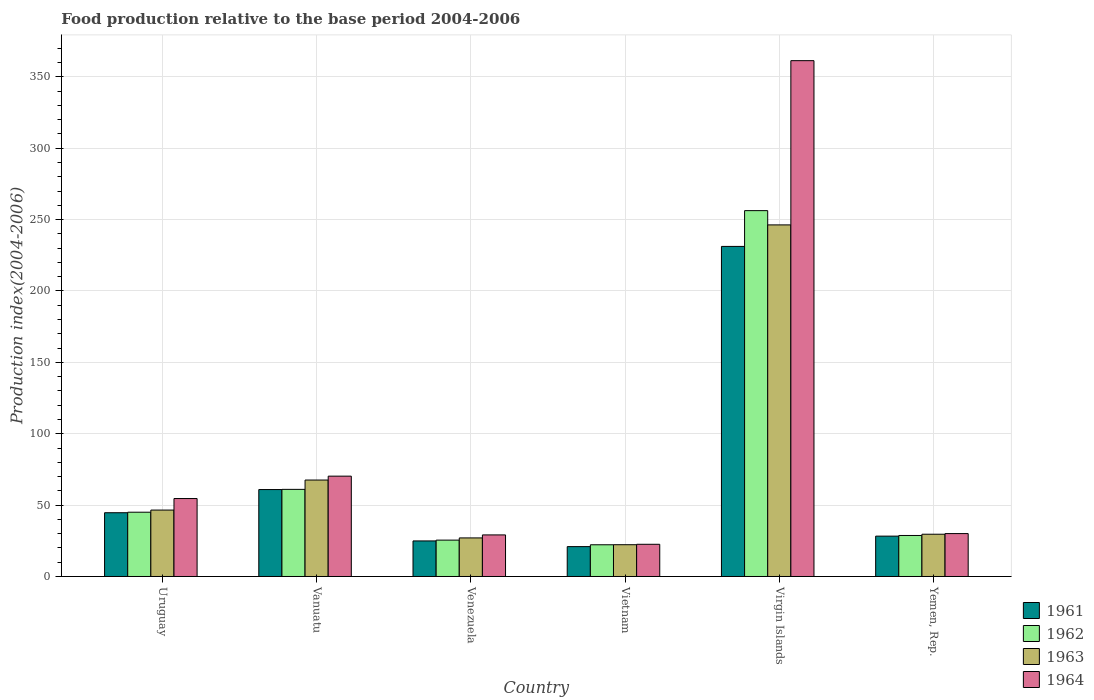How many groups of bars are there?
Provide a short and direct response. 6. Are the number of bars per tick equal to the number of legend labels?
Provide a succinct answer. Yes. Are the number of bars on each tick of the X-axis equal?
Your response must be concise. Yes. How many bars are there on the 5th tick from the right?
Your answer should be very brief. 4. What is the label of the 3rd group of bars from the left?
Your answer should be very brief. Venezuela. What is the food production index in 1961 in Vanuatu?
Your response must be concise. 60.9. Across all countries, what is the maximum food production index in 1961?
Provide a succinct answer. 231.21. Across all countries, what is the minimum food production index in 1964?
Provide a short and direct response. 22.56. In which country was the food production index in 1962 maximum?
Provide a short and direct response. Virgin Islands. In which country was the food production index in 1963 minimum?
Your response must be concise. Vietnam. What is the total food production index in 1964 in the graph?
Offer a terse response. 567.94. What is the difference between the food production index in 1962 in Vanuatu and that in Vietnam?
Your answer should be compact. 38.81. What is the difference between the food production index in 1961 in Vietnam and the food production index in 1962 in Uruguay?
Offer a terse response. -24.1. What is the average food production index in 1962 per country?
Provide a short and direct response. 73.12. What is the difference between the food production index of/in 1961 and food production index of/in 1964 in Virgin Islands?
Your answer should be very brief. -130.11. In how many countries, is the food production index in 1962 greater than 10?
Keep it short and to the point. 6. What is the ratio of the food production index in 1964 in Uruguay to that in Virgin Islands?
Offer a very short reply. 0.15. Is the food production index in 1963 in Venezuela less than that in Virgin Islands?
Provide a short and direct response. Yes. Is the difference between the food production index in 1961 in Venezuela and Virgin Islands greater than the difference between the food production index in 1964 in Venezuela and Virgin Islands?
Provide a succinct answer. Yes. What is the difference between the highest and the second highest food production index in 1964?
Provide a succinct answer. -306.72. What is the difference between the highest and the lowest food production index in 1962?
Your answer should be compact. 234.05. In how many countries, is the food production index in 1964 greater than the average food production index in 1964 taken over all countries?
Offer a very short reply. 1. What does the 2nd bar from the right in Venezuela represents?
Keep it short and to the point. 1963. What is the difference between two consecutive major ticks on the Y-axis?
Offer a very short reply. 50. Does the graph contain grids?
Your answer should be very brief. Yes. What is the title of the graph?
Give a very brief answer. Food production relative to the base period 2004-2006. Does "2011" appear as one of the legend labels in the graph?
Offer a very short reply. No. What is the label or title of the X-axis?
Provide a short and direct response. Country. What is the label or title of the Y-axis?
Offer a terse response. Production index(2004-2006). What is the Production index(2004-2006) of 1961 in Uruguay?
Your answer should be very brief. 44.66. What is the Production index(2004-2006) of 1962 in Uruguay?
Provide a short and direct response. 45.02. What is the Production index(2004-2006) of 1963 in Uruguay?
Keep it short and to the point. 46.52. What is the Production index(2004-2006) in 1964 in Uruguay?
Offer a terse response. 54.6. What is the Production index(2004-2006) of 1961 in Vanuatu?
Provide a short and direct response. 60.9. What is the Production index(2004-2006) of 1962 in Vanuatu?
Give a very brief answer. 61.03. What is the Production index(2004-2006) of 1963 in Vanuatu?
Your answer should be compact. 67.56. What is the Production index(2004-2006) in 1964 in Vanuatu?
Give a very brief answer. 70.29. What is the Production index(2004-2006) in 1961 in Venezuela?
Provide a short and direct response. 24.91. What is the Production index(2004-2006) in 1962 in Venezuela?
Provide a succinct answer. 25.48. What is the Production index(2004-2006) in 1963 in Venezuela?
Keep it short and to the point. 27.02. What is the Production index(2004-2006) of 1964 in Venezuela?
Make the answer very short. 29.12. What is the Production index(2004-2006) in 1961 in Vietnam?
Give a very brief answer. 20.92. What is the Production index(2004-2006) of 1962 in Vietnam?
Make the answer very short. 22.22. What is the Production index(2004-2006) in 1963 in Vietnam?
Make the answer very short. 22.26. What is the Production index(2004-2006) of 1964 in Vietnam?
Keep it short and to the point. 22.56. What is the Production index(2004-2006) in 1961 in Virgin Islands?
Offer a very short reply. 231.21. What is the Production index(2004-2006) in 1962 in Virgin Islands?
Keep it short and to the point. 256.27. What is the Production index(2004-2006) in 1963 in Virgin Islands?
Your answer should be compact. 246.28. What is the Production index(2004-2006) in 1964 in Virgin Islands?
Make the answer very short. 361.32. What is the Production index(2004-2006) in 1961 in Yemen, Rep.?
Provide a short and direct response. 28.27. What is the Production index(2004-2006) in 1962 in Yemen, Rep.?
Keep it short and to the point. 28.73. What is the Production index(2004-2006) of 1963 in Yemen, Rep.?
Keep it short and to the point. 29.6. What is the Production index(2004-2006) in 1964 in Yemen, Rep.?
Provide a short and direct response. 30.05. Across all countries, what is the maximum Production index(2004-2006) in 1961?
Your answer should be very brief. 231.21. Across all countries, what is the maximum Production index(2004-2006) of 1962?
Keep it short and to the point. 256.27. Across all countries, what is the maximum Production index(2004-2006) in 1963?
Give a very brief answer. 246.28. Across all countries, what is the maximum Production index(2004-2006) of 1964?
Offer a terse response. 361.32. Across all countries, what is the minimum Production index(2004-2006) in 1961?
Keep it short and to the point. 20.92. Across all countries, what is the minimum Production index(2004-2006) of 1962?
Keep it short and to the point. 22.22. Across all countries, what is the minimum Production index(2004-2006) of 1963?
Your response must be concise. 22.26. Across all countries, what is the minimum Production index(2004-2006) of 1964?
Your answer should be very brief. 22.56. What is the total Production index(2004-2006) in 1961 in the graph?
Your response must be concise. 410.87. What is the total Production index(2004-2006) of 1962 in the graph?
Your answer should be very brief. 438.75. What is the total Production index(2004-2006) of 1963 in the graph?
Your answer should be very brief. 439.24. What is the total Production index(2004-2006) in 1964 in the graph?
Provide a short and direct response. 567.94. What is the difference between the Production index(2004-2006) of 1961 in Uruguay and that in Vanuatu?
Your response must be concise. -16.24. What is the difference between the Production index(2004-2006) of 1962 in Uruguay and that in Vanuatu?
Provide a short and direct response. -16.01. What is the difference between the Production index(2004-2006) of 1963 in Uruguay and that in Vanuatu?
Your response must be concise. -21.04. What is the difference between the Production index(2004-2006) of 1964 in Uruguay and that in Vanuatu?
Your response must be concise. -15.69. What is the difference between the Production index(2004-2006) of 1961 in Uruguay and that in Venezuela?
Keep it short and to the point. 19.75. What is the difference between the Production index(2004-2006) in 1962 in Uruguay and that in Venezuela?
Offer a very short reply. 19.54. What is the difference between the Production index(2004-2006) in 1963 in Uruguay and that in Venezuela?
Your answer should be very brief. 19.5. What is the difference between the Production index(2004-2006) of 1964 in Uruguay and that in Venezuela?
Your answer should be very brief. 25.48. What is the difference between the Production index(2004-2006) of 1961 in Uruguay and that in Vietnam?
Ensure brevity in your answer.  23.74. What is the difference between the Production index(2004-2006) in 1962 in Uruguay and that in Vietnam?
Offer a very short reply. 22.8. What is the difference between the Production index(2004-2006) of 1963 in Uruguay and that in Vietnam?
Offer a terse response. 24.26. What is the difference between the Production index(2004-2006) in 1964 in Uruguay and that in Vietnam?
Your answer should be compact. 32.04. What is the difference between the Production index(2004-2006) of 1961 in Uruguay and that in Virgin Islands?
Offer a terse response. -186.55. What is the difference between the Production index(2004-2006) of 1962 in Uruguay and that in Virgin Islands?
Your answer should be compact. -211.25. What is the difference between the Production index(2004-2006) in 1963 in Uruguay and that in Virgin Islands?
Your answer should be compact. -199.76. What is the difference between the Production index(2004-2006) of 1964 in Uruguay and that in Virgin Islands?
Your response must be concise. -306.72. What is the difference between the Production index(2004-2006) of 1961 in Uruguay and that in Yemen, Rep.?
Your answer should be compact. 16.39. What is the difference between the Production index(2004-2006) in 1962 in Uruguay and that in Yemen, Rep.?
Offer a terse response. 16.29. What is the difference between the Production index(2004-2006) of 1963 in Uruguay and that in Yemen, Rep.?
Your answer should be very brief. 16.92. What is the difference between the Production index(2004-2006) in 1964 in Uruguay and that in Yemen, Rep.?
Provide a succinct answer. 24.55. What is the difference between the Production index(2004-2006) in 1961 in Vanuatu and that in Venezuela?
Offer a terse response. 35.99. What is the difference between the Production index(2004-2006) in 1962 in Vanuatu and that in Venezuela?
Ensure brevity in your answer.  35.55. What is the difference between the Production index(2004-2006) of 1963 in Vanuatu and that in Venezuela?
Your answer should be very brief. 40.54. What is the difference between the Production index(2004-2006) of 1964 in Vanuatu and that in Venezuela?
Your answer should be compact. 41.17. What is the difference between the Production index(2004-2006) of 1961 in Vanuatu and that in Vietnam?
Ensure brevity in your answer.  39.98. What is the difference between the Production index(2004-2006) in 1962 in Vanuatu and that in Vietnam?
Keep it short and to the point. 38.81. What is the difference between the Production index(2004-2006) in 1963 in Vanuatu and that in Vietnam?
Make the answer very short. 45.3. What is the difference between the Production index(2004-2006) of 1964 in Vanuatu and that in Vietnam?
Your answer should be compact. 47.73. What is the difference between the Production index(2004-2006) in 1961 in Vanuatu and that in Virgin Islands?
Give a very brief answer. -170.31. What is the difference between the Production index(2004-2006) of 1962 in Vanuatu and that in Virgin Islands?
Provide a succinct answer. -195.24. What is the difference between the Production index(2004-2006) in 1963 in Vanuatu and that in Virgin Islands?
Provide a succinct answer. -178.72. What is the difference between the Production index(2004-2006) of 1964 in Vanuatu and that in Virgin Islands?
Provide a succinct answer. -291.03. What is the difference between the Production index(2004-2006) of 1961 in Vanuatu and that in Yemen, Rep.?
Keep it short and to the point. 32.63. What is the difference between the Production index(2004-2006) in 1962 in Vanuatu and that in Yemen, Rep.?
Offer a very short reply. 32.3. What is the difference between the Production index(2004-2006) in 1963 in Vanuatu and that in Yemen, Rep.?
Give a very brief answer. 37.96. What is the difference between the Production index(2004-2006) in 1964 in Vanuatu and that in Yemen, Rep.?
Your answer should be compact. 40.24. What is the difference between the Production index(2004-2006) of 1961 in Venezuela and that in Vietnam?
Your response must be concise. 3.99. What is the difference between the Production index(2004-2006) of 1962 in Venezuela and that in Vietnam?
Offer a terse response. 3.26. What is the difference between the Production index(2004-2006) of 1963 in Venezuela and that in Vietnam?
Give a very brief answer. 4.76. What is the difference between the Production index(2004-2006) in 1964 in Venezuela and that in Vietnam?
Ensure brevity in your answer.  6.56. What is the difference between the Production index(2004-2006) in 1961 in Venezuela and that in Virgin Islands?
Give a very brief answer. -206.3. What is the difference between the Production index(2004-2006) of 1962 in Venezuela and that in Virgin Islands?
Your response must be concise. -230.79. What is the difference between the Production index(2004-2006) in 1963 in Venezuela and that in Virgin Islands?
Your response must be concise. -219.26. What is the difference between the Production index(2004-2006) in 1964 in Venezuela and that in Virgin Islands?
Your response must be concise. -332.2. What is the difference between the Production index(2004-2006) in 1961 in Venezuela and that in Yemen, Rep.?
Your response must be concise. -3.36. What is the difference between the Production index(2004-2006) in 1962 in Venezuela and that in Yemen, Rep.?
Keep it short and to the point. -3.25. What is the difference between the Production index(2004-2006) of 1963 in Venezuela and that in Yemen, Rep.?
Your answer should be very brief. -2.58. What is the difference between the Production index(2004-2006) in 1964 in Venezuela and that in Yemen, Rep.?
Your answer should be compact. -0.93. What is the difference between the Production index(2004-2006) in 1961 in Vietnam and that in Virgin Islands?
Provide a short and direct response. -210.29. What is the difference between the Production index(2004-2006) in 1962 in Vietnam and that in Virgin Islands?
Ensure brevity in your answer.  -234.05. What is the difference between the Production index(2004-2006) of 1963 in Vietnam and that in Virgin Islands?
Your response must be concise. -224.02. What is the difference between the Production index(2004-2006) of 1964 in Vietnam and that in Virgin Islands?
Offer a very short reply. -338.76. What is the difference between the Production index(2004-2006) in 1961 in Vietnam and that in Yemen, Rep.?
Give a very brief answer. -7.35. What is the difference between the Production index(2004-2006) of 1962 in Vietnam and that in Yemen, Rep.?
Your answer should be compact. -6.51. What is the difference between the Production index(2004-2006) in 1963 in Vietnam and that in Yemen, Rep.?
Provide a succinct answer. -7.34. What is the difference between the Production index(2004-2006) in 1964 in Vietnam and that in Yemen, Rep.?
Provide a succinct answer. -7.49. What is the difference between the Production index(2004-2006) of 1961 in Virgin Islands and that in Yemen, Rep.?
Provide a short and direct response. 202.94. What is the difference between the Production index(2004-2006) of 1962 in Virgin Islands and that in Yemen, Rep.?
Make the answer very short. 227.54. What is the difference between the Production index(2004-2006) of 1963 in Virgin Islands and that in Yemen, Rep.?
Your answer should be very brief. 216.68. What is the difference between the Production index(2004-2006) of 1964 in Virgin Islands and that in Yemen, Rep.?
Provide a succinct answer. 331.27. What is the difference between the Production index(2004-2006) of 1961 in Uruguay and the Production index(2004-2006) of 1962 in Vanuatu?
Provide a succinct answer. -16.37. What is the difference between the Production index(2004-2006) of 1961 in Uruguay and the Production index(2004-2006) of 1963 in Vanuatu?
Provide a short and direct response. -22.9. What is the difference between the Production index(2004-2006) of 1961 in Uruguay and the Production index(2004-2006) of 1964 in Vanuatu?
Keep it short and to the point. -25.63. What is the difference between the Production index(2004-2006) in 1962 in Uruguay and the Production index(2004-2006) in 1963 in Vanuatu?
Make the answer very short. -22.54. What is the difference between the Production index(2004-2006) of 1962 in Uruguay and the Production index(2004-2006) of 1964 in Vanuatu?
Your answer should be compact. -25.27. What is the difference between the Production index(2004-2006) in 1963 in Uruguay and the Production index(2004-2006) in 1964 in Vanuatu?
Ensure brevity in your answer.  -23.77. What is the difference between the Production index(2004-2006) in 1961 in Uruguay and the Production index(2004-2006) in 1962 in Venezuela?
Your answer should be very brief. 19.18. What is the difference between the Production index(2004-2006) of 1961 in Uruguay and the Production index(2004-2006) of 1963 in Venezuela?
Keep it short and to the point. 17.64. What is the difference between the Production index(2004-2006) of 1961 in Uruguay and the Production index(2004-2006) of 1964 in Venezuela?
Make the answer very short. 15.54. What is the difference between the Production index(2004-2006) in 1962 in Uruguay and the Production index(2004-2006) in 1964 in Venezuela?
Give a very brief answer. 15.9. What is the difference between the Production index(2004-2006) in 1961 in Uruguay and the Production index(2004-2006) in 1962 in Vietnam?
Provide a succinct answer. 22.44. What is the difference between the Production index(2004-2006) in 1961 in Uruguay and the Production index(2004-2006) in 1963 in Vietnam?
Your answer should be compact. 22.4. What is the difference between the Production index(2004-2006) of 1961 in Uruguay and the Production index(2004-2006) of 1964 in Vietnam?
Offer a very short reply. 22.1. What is the difference between the Production index(2004-2006) of 1962 in Uruguay and the Production index(2004-2006) of 1963 in Vietnam?
Offer a very short reply. 22.76. What is the difference between the Production index(2004-2006) of 1962 in Uruguay and the Production index(2004-2006) of 1964 in Vietnam?
Your response must be concise. 22.46. What is the difference between the Production index(2004-2006) in 1963 in Uruguay and the Production index(2004-2006) in 1964 in Vietnam?
Keep it short and to the point. 23.96. What is the difference between the Production index(2004-2006) in 1961 in Uruguay and the Production index(2004-2006) in 1962 in Virgin Islands?
Provide a succinct answer. -211.61. What is the difference between the Production index(2004-2006) in 1961 in Uruguay and the Production index(2004-2006) in 1963 in Virgin Islands?
Ensure brevity in your answer.  -201.62. What is the difference between the Production index(2004-2006) of 1961 in Uruguay and the Production index(2004-2006) of 1964 in Virgin Islands?
Make the answer very short. -316.66. What is the difference between the Production index(2004-2006) of 1962 in Uruguay and the Production index(2004-2006) of 1963 in Virgin Islands?
Offer a terse response. -201.26. What is the difference between the Production index(2004-2006) in 1962 in Uruguay and the Production index(2004-2006) in 1964 in Virgin Islands?
Make the answer very short. -316.3. What is the difference between the Production index(2004-2006) in 1963 in Uruguay and the Production index(2004-2006) in 1964 in Virgin Islands?
Offer a very short reply. -314.8. What is the difference between the Production index(2004-2006) of 1961 in Uruguay and the Production index(2004-2006) of 1962 in Yemen, Rep.?
Your answer should be compact. 15.93. What is the difference between the Production index(2004-2006) of 1961 in Uruguay and the Production index(2004-2006) of 1963 in Yemen, Rep.?
Your answer should be compact. 15.06. What is the difference between the Production index(2004-2006) in 1961 in Uruguay and the Production index(2004-2006) in 1964 in Yemen, Rep.?
Keep it short and to the point. 14.61. What is the difference between the Production index(2004-2006) in 1962 in Uruguay and the Production index(2004-2006) in 1963 in Yemen, Rep.?
Make the answer very short. 15.42. What is the difference between the Production index(2004-2006) of 1962 in Uruguay and the Production index(2004-2006) of 1964 in Yemen, Rep.?
Give a very brief answer. 14.97. What is the difference between the Production index(2004-2006) of 1963 in Uruguay and the Production index(2004-2006) of 1964 in Yemen, Rep.?
Offer a very short reply. 16.47. What is the difference between the Production index(2004-2006) in 1961 in Vanuatu and the Production index(2004-2006) in 1962 in Venezuela?
Your answer should be compact. 35.42. What is the difference between the Production index(2004-2006) of 1961 in Vanuatu and the Production index(2004-2006) of 1963 in Venezuela?
Make the answer very short. 33.88. What is the difference between the Production index(2004-2006) in 1961 in Vanuatu and the Production index(2004-2006) in 1964 in Venezuela?
Make the answer very short. 31.78. What is the difference between the Production index(2004-2006) of 1962 in Vanuatu and the Production index(2004-2006) of 1963 in Venezuela?
Provide a short and direct response. 34.01. What is the difference between the Production index(2004-2006) of 1962 in Vanuatu and the Production index(2004-2006) of 1964 in Venezuela?
Keep it short and to the point. 31.91. What is the difference between the Production index(2004-2006) in 1963 in Vanuatu and the Production index(2004-2006) in 1964 in Venezuela?
Offer a terse response. 38.44. What is the difference between the Production index(2004-2006) of 1961 in Vanuatu and the Production index(2004-2006) of 1962 in Vietnam?
Your response must be concise. 38.68. What is the difference between the Production index(2004-2006) of 1961 in Vanuatu and the Production index(2004-2006) of 1963 in Vietnam?
Offer a terse response. 38.64. What is the difference between the Production index(2004-2006) in 1961 in Vanuatu and the Production index(2004-2006) in 1964 in Vietnam?
Ensure brevity in your answer.  38.34. What is the difference between the Production index(2004-2006) in 1962 in Vanuatu and the Production index(2004-2006) in 1963 in Vietnam?
Ensure brevity in your answer.  38.77. What is the difference between the Production index(2004-2006) in 1962 in Vanuatu and the Production index(2004-2006) in 1964 in Vietnam?
Your response must be concise. 38.47. What is the difference between the Production index(2004-2006) in 1961 in Vanuatu and the Production index(2004-2006) in 1962 in Virgin Islands?
Give a very brief answer. -195.37. What is the difference between the Production index(2004-2006) of 1961 in Vanuatu and the Production index(2004-2006) of 1963 in Virgin Islands?
Ensure brevity in your answer.  -185.38. What is the difference between the Production index(2004-2006) in 1961 in Vanuatu and the Production index(2004-2006) in 1964 in Virgin Islands?
Ensure brevity in your answer.  -300.42. What is the difference between the Production index(2004-2006) in 1962 in Vanuatu and the Production index(2004-2006) in 1963 in Virgin Islands?
Ensure brevity in your answer.  -185.25. What is the difference between the Production index(2004-2006) in 1962 in Vanuatu and the Production index(2004-2006) in 1964 in Virgin Islands?
Provide a succinct answer. -300.29. What is the difference between the Production index(2004-2006) in 1963 in Vanuatu and the Production index(2004-2006) in 1964 in Virgin Islands?
Your response must be concise. -293.76. What is the difference between the Production index(2004-2006) of 1961 in Vanuatu and the Production index(2004-2006) of 1962 in Yemen, Rep.?
Your answer should be very brief. 32.17. What is the difference between the Production index(2004-2006) in 1961 in Vanuatu and the Production index(2004-2006) in 1963 in Yemen, Rep.?
Provide a succinct answer. 31.3. What is the difference between the Production index(2004-2006) in 1961 in Vanuatu and the Production index(2004-2006) in 1964 in Yemen, Rep.?
Offer a terse response. 30.85. What is the difference between the Production index(2004-2006) of 1962 in Vanuatu and the Production index(2004-2006) of 1963 in Yemen, Rep.?
Your answer should be very brief. 31.43. What is the difference between the Production index(2004-2006) of 1962 in Vanuatu and the Production index(2004-2006) of 1964 in Yemen, Rep.?
Your answer should be very brief. 30.98. What is the difference between the Production index(2004-2006) of 1963 in Vanuatu and the Production index(2004-2006) of 1964 in Yemen, Rep.?
Provide a succinct answer. 37.51. What is the difference between the Production index(2004-2006) in 1961 in Venezuela and the Production index(2004-2006) in 1962 in Vietnam?
Keep it short and to the point. 2.69. What is the difference between the Production index(2004-2006) in 1961 in Venezuela and the Production index(2004-2006) in 1963 in Vietnam?
Your answer should be compact. 2.65. What is the difference between the Production index(2004-2006) of 1961 in Venezuela and the Production index(2004-2006) of 1964 in Vietnam?
Your answer should be very brief. 2.35. What is the difference between the Production index(2004-2006) of 1962 in Venezuela and the Production index(2004-2006) of 1963 in Vietnam?
Your answer should be very brief. 3.22. What is the difference between the Production index(2004-2006) in 1962 in Venezuela and the Production index(2004-2006) in 1964 in Vietnam?
Offer a very short reply. 2.92. What is the difference between the Production index(2004-2006) in 1963 in Venezuela and the Production index(2004-2006) in 1964 in Vietnam?
Your answer should be very brief. 4.46. What is the difference between the Production index(2004-2006) of 1961 in Venezuela and the Production index(2004-2006) of 1962 in Virgin Islands?
Make the answer very short. -231.36. What is the difference between the Production index(2004-2006) of 1961 in Venezuela and the Production index(2004-2006) of 1963 in Virgin Islands?
Your answer should be very brief. -221.37. What is the difference between the Production index(2004-2006) in 1961 in Venezuela and the Production index(2004-2006) in 1964 in Virgin Islands?
Provide a short and direct response. -336.41. What is the difference between the Production index(2004-2006) of 1962 in Venezuela and the Production index(2004-2006) of 1963 in Virgin Islands?
Keep it short and to the point. -220.8. What is the difference between the Production index(2004-2006) of 1962 in Venezuela and the Production index(2004-2006) of 1964 in Virgin Islands?
Provide a short and direct response. -335.84. What is the difference between the Production index(2004-2006) in 1963 in Venezuela and the Production index(2004-2006) in 1964 in Virgin Islands?
Provide a short and direct response. -334.3. What is the difference between the Production index(2004-2006) of 1961 in Venezuela and the Production index(2004-2006) of 1962 in Yemen, Rep.?
Provide a short and direct response. -3.82. What is the difference between the Production index(2004-2006) of 1961 in Venezuela and the Production index(2004-2006) of 1963 in Yemen, Rep.?
Your response must be concise. -4.69. What is the difference between the Production index(2004-2006) of 1961 in Venezuela and the Production index(2004-2006) of 1964 in Yemen, Rep.?
Offer a very short reply. -5.14. What is the difference between the Production index(2004-2006) of 1962 in Venezuela and the Production index(2004-2006) of 1963 in Yemen, Rep.?
Your answer should be compact. -4.12. What is the difference between the Production index(2004-2006) of 1962 in Venezuela and the Production index(2004-2006) of 1964 in Yemen, Rep.?
Provide a succinct answer. -4.57. What is the difference between the Production index(2004-2006) in 1963 in Venezuela and the Production index(2004-2006) in 1964 in Yemen, Rep.?
Provide a short and direct response. -3.03. What is the difference between the Production index(2004-2006) of 1961 in Vietnam and the Production index(2004-2006) of 1962 in Virgin Islands?
Offer a terse response. -235.35. What is the difference between the Production index(2004-2006) of 1961 in Vietnam and the Production index(2004-2006) of 1963 in Virgin Islands?
Offer a very short reply. -225.36. What is the difference between the Production index(2004-2006) of 1961 in Vietnam and the Production index(2004-2006) of 1964 in Virgin Islands?
Your response must be concise. -340.4. What is the difference between the Production index(2004-2006) in 1962 in Vietnam and the Production index(2004-2006) in 1963 in Virgin Islands?
Your response must be concise. -224.06. What is the difference between the Production index(2004-2006) in 1962 in Vietnam and the Production index(2004-2006) in 1964 in Virgin Islands?
Ensure brevity in your answer.  -339.1. What is the difference between the Production index(2004-2006) in 1963 in Vietnam and the Production index(2004-2006) in 1964 in Virgin Islands?
Offer a very short reply. -339.06. What is the difference between the Production index(2004-2006) of 1961 in Vietnam and the Production index(2004-2006) of 1962 in Yemen, Rep.?
Provide a short and direct response. -7.81. What is the difference between the Production index(2004-2006) of 1961 in Vietnam and the Production index(2004-2006) of 1963 in Yemen, Rep.?
Make the answer very short. -8.68. What is the difference between the Production index(2004-2006) in 1961 in Vietnam and the Production index(2004-2006) in 1964 in Yemen, Rep.?
Keep it short and to the point. -9.13. What is the difference between the Production index(2004-2006) in 1962 in Vietnam and the Production index(2004-2006) in 1963 in Yemen, Rep.?
Your answer should be compact. -7.38. What is the difference between the Production index(2004-2006) in 1962 in Vietnam and the Production index(2004-2006) in 1964 in Yemen, Rep.?
Your answer should be compact. -7.83. What is the difference between the Production index(2004-2006) in 1963 in Vietnam and the Production index(2004-2006) in 1964 in Yemen, Rep.?
Provide a short and direct response. -7.79. What is the difference between the Production index(2004-2006) of 1961 in Virgin Islands and the Production index(2004-2006) of 1962 in Yemen, Rep.?
Your response must be concise. 202.48. What is the difference between the Production index(2004-2006) of 1961 in Virgin Islands and the Production index(2004-2006) of 1963 in Yemen, Rep.?
Offer a very short reply. 201.61. What is the difference between the Production index(2004-2006) in 1961 in Virgin Islands and the Production index(2004-2006) in 1964 in Yemen, Rep.?
Give a very brief answer. 201.16. What is the difference between the Production index(2004-2006) in 1962 in Virgin Islands and the Production index(2004-2006) in 1963 in Yemen, Rep.?
Provide a succinct answer. 226.67. What is the difference between the Production index(2004-2006) of 1962 in Virgin Islands and the Production index(2004-2006) of 1964 in Yemen, Rep.?
Ensure brevity in your answer.  226.22. What is the difference between the Production index(2004-2006) of 1963 in Virgin Islands and the Production index(2004-2006) of 1964 in Yemen, Rep.?
Give a very brief answer. 216.23. What is the average Production index(2004-2006) of 1961 per country?
Offer a very short reply. 68.48. What is the average Production index(2004-2006) in 1962 per country?
Make the answer very short. 73.12. What is the average Production index(2004-2006) in 1963 per country?
Provide a succinct answer. 73.21. What is the average Production index(2004-2006) in 1964 per country?
Your answer should be compact. 94.66. What is the difference between the Production index(2004-2006) in 1961 and Production index(2004-2006) in 1962 in Uruguay?
Ensure brevity in your answer.  -0.36. What is the difference between the Production index(2004-2006) of 1961 and Production index(2004-2006) of 1963 in Uruguay?
Ensure brevity in your answer.  -1.86. What is the difference between the Production index(2004-2006) of 1961 and Production index(2004-2006) of 1964 in Uruguay?
Offer a very short reply. -9.94. What is the difference between the Production index(2004-2006) of 1962 and Production index(2004-2006) of 1964 in Uruguay?
Ensure brevity in your answer.  -9.58. What is the difference between the Production index(2004-2006) of 1963 and Production index(2004-2006) of 1964 in Uruguay?
Provide a succinct answer. -8.08. What is the difference between the Production index(2004-2006) of 1961 and Production index(2004-2006) of 1962 in Vanuatu?
Offer a terse response. -0.13. What is the difference between the Production index(2004-2006) of 1961 and Production index(2004-2006) of 1963 in Vanuatu?
Keep it short and to the point. -6.66. What is the difference between the Production index(2004-2006) of 1961 and Production index(2004-2006) of 1964 in Vanuatu?
Keep it short and to the point. -9.39. What is the difference between the Production index(2004-2006) of 1962 and Production index(2004-2006) of 1963 in Vanuatu?
Give a very brief answer. -6.53. What is the difference between the Production index(2004-2006) of 1962 and Production index(2004-2006) of 1964 in Vanuatu?
Ensure brevity in your answer.  -9.26. What is the difference between the Production index(2004-2006) in 1963 and Production index(2004-2006) in 1964 in Vanuatu?
Provide a short and direct response. -2.73. What is the difference between the Production index(2004-2006) of 1961 and Production index(2004-2006) of 1962 in Venezuela?
Offer a very short reply. -0.57. What is the difference between the Production index(2004-2006) of 1961 and Production index(2004-2006) of 1963 in Venezuela?
Provide a succinct answer. -2.11. What is the difference between the Production index(2004-2006) of 1961 and Production index(2004-2006) of 1964 in Venezuela?
Offer a terse response. -4.21. What is the difference between the Production index(2004-2006) in 1962 and Production index(2004-2006) in 1963 in Venezuela?
Make the answer very short. -1.54. What is the difference between the Production index(2004-2006) of 1962 and Production index(2004-2006) of 1964 in Venezuela?
Provide a succinct answer. -3.64. What is the difference between the Production index(2004-2006) in 1961 and Production index(2004-2006) in 1963 in Vietnam?
Offer a terse response. -1.34. What is the difference between the Production index(2004-2006) of 1961 and Production index(2004-2006) of 1964 in Vietnam?
Your answer should be compact. -1.64. What is the difference between the Production index(2004-2006) in 1962 and Production index(2004-2006) in 1963 in Vietnam?
Keep it short and to the point. -0.04. What is the difference between the Production index(2004-2006) in 1962 and Production index(2004-2006) in 1964 in Vietnam?
Offer a terse response. -0.34. What is the difference between the Production index(2004-2006) of 1961 and Production index(2004-2006) of 1962 in Virgin Islands?
Give a very brief answer. -25.06. What is the difference between the Production index(2004-2006) of 1961 and Production index(2004-2006) of 1963 in Virgin Islands?
Provide a succinct answer. -15.07. What is the difference between the Production index(2004-2006) in 1961 and Production index(2004-2006) in 1964 in Virgin Islands?
Provide a succinct answer. -130.11. What is the difference between the Production index(2004-2006) in 1962 and Production index(2004-2006) in 1963 in Virgin Islands?
Offer a very short reply. 9.99. What is the difference between the Production index(2004-2006) in 1962 and Production index(2004-2006) in 1964 in Virgin Islands?
Your response must be concise. -105.05. What is the difference between the Production index(2004-2006) in 1963 and Production index(2004-2006) in 1964 in Virgin Islands?
Provide a short and direct response. -115.04. What is the difference between the Production index(2004-2006) of 1961 and Production index(2004-2006) of 1962 in Yemen, Rep.?
Keep it short and to the point. -0.46. What is the difference between the Production index(2004-2006) of 1961 and Production index(2004-2006) of 1963 in Yemen, Rep.?
Offer a very short reply. -1.33. What is the difference between the Production index(2004-2006) in 1961 and Production index(2004-2006) in 1964 in Yemen, Rep.?
Offer a terse response. -1.78. What is the difference between the Production index(2004-2006) of 1962 and Production index(2004-2006) of 1963 in Yemen, Rep.?
Offer a terse response. -0.87. What is the difference between the Production index(2004-2006) in 1962 and Production index(2004-2006) in 1964 in Yemen, Rep.?
Offer a very short reply. -1.32. What is the difference between the Production index(2004-2006) in 1963 and Production index(2004-2006) in 1964 in Yemen, Rep.?
Ensure brevity in your answer.  -0.45. What is the ratio of the Production index(2004-2006) in 1961 in Uruguay to that in Vanuatu?
Keep it short and to the point. 0.73. What is the ratio of the Production index(2004-2006) of 1962 in Uruguay to that in Vanuatu?
Offer a very short reply. 0.74. What is the ratio of the Production index(2004-2006) of 1963 in Uruguay to that in Vanuatu?
Provide a succinct answer. 0.69. What is the ratio of the Production index(2004-2006) of 1964 in Uruguay to that in Vanuatu?
Keep it short and to the point. 0.78. What is the ratio of the Production index(2004-2006) of 1961 in Uruguay to that in Venezuela?
Ensure brevity in your answer.  1.79. What is the ratio of the Production index(2004-2006) in 1962 in Uruguay to that in Venezuela?
Your answer should be compact. 1.77. What is the ratio of the Production index(2004-2006) in 1963 in Uruguay to that in Venezuela?
Make the answer very short. 1.72. What is the ratio of the Production index(2004-2006) of 1964 in Uruguay to that in Venezuela?
Keep it short and to the point. 1.88. What is the ratio of the Production index(2004-2006) in 1961 in Uruguay to that in Vietnam?
Give a very brief answer. 2.13. What is the ratio of the Production index(2004-2006) of 1962 in Uruguay to that in Vietnam?
Give a very brief answer. 2.03. What is the ratio of the Production index(2004-2006) in 1963 in Uruguay to that in Vietnam?
Provide a succinct answer. 2.09. What is the ratio of the Production index(2004-2006) of 1964 in Uruguay to that in Vietnam?
Your answer should be very brief. 2.42. What is the ratio of the Production index(2004-2006) of 1961 in Uruguay to that in Virgin Islands?
Keep it short and to the point. 0.19. What is the ratio of the Production index(2004-2006) of 1962 in Uruguay to that in Virgin Islands?
Your answer should be very brief. 0.18. What is the ratio of the Production index(2004-2006) of 1963 in Uruguay to that in Virgin Islands?
Make the answer very short. 0.19. What is the ratio of the Production index(2004-2006) of 1964 in Uruguay to that in Virgin Islands?
Make the answer very short. 0.15. What is the ratio of the Production index(2004-2006) of 1961 in Uruguay to that in Yemen, Rep.?
Provide a succinct answer. 1.58. What is the ratio of the Production index(2004-2006) of 1962 in Uruguay to that in Yemen, Rep.?
Ensure brevity in your answer.  1.57. What is the ratio of the Production index(2004-2006) in 1963 in Uruguay to that in Yemen, Rep.?
Offer a very short reply. 1.57. What is the ratio of the Production index(2004-2006) in 1964 in Uruguay to that in Yemen, Rep.?
Offer a very short reply. 1.82. What is the ratio of the Production index(2004-2006) of 1961 in Vanuatu to that in Venezuela?
Provide a succinct answer. 2.44. What is the ratio of the Production index(2004-2006) of 1962 in Vanuatu to that in Venezuela?
Your answer should be compact. 2.4. What is the ratio of the Production index(2004-2006) of 1963 in Vanuatu to that in Venezuela?
Ensure brevity in your answer.  2.5. What is the ratio of the Production index(2004-2006) of 1964 in Vanuatu to that in Venezuela?
Give a very brief answer. 2.41. What is the ratio of the Production index(2004-2006) of 1961 in Vanuatu to that in Vietnam?
Your response must be concise. 2.91. What is the ratio of the Production index(2004-2006) of 1962 in Vanuatu to that in Vietnam?
Give a very brief answer. 2.75. What is the ratio of the Production index(2004-2006) of 1963 in Vanuatu to that in Vietnam?
Your answer should be compact. 3.04. What is the ratio of the Production index(2004-2006) in 1964 in Vanuatu to that in Vietnam?
Your answer should be very brief. 3.12. What is the ratio of the Production index(2004-2006) of 1961 in Vanuatu to that in Virgin Islands?
Offer a very short reply. 0.26. What is the ratio of the Production index(2004-2006) in 1962 in Vanuatu to that in Virgin Islands?
Your response must be concise. 0.24. What is the ratio of the Production index(2004-2006) in 1963 in Vanuatu to that in Virgin Islands?
Keep it short and to the point. 0.27. What is the ratio of the Production index(2004-2006) in 1964 in Vanuatu to that in Virgin Islands?
Provide a short and direct response. 0.19. What is the ratio of the Production index(2004-2006) in 1961 in Vanuatu to that in Yemen, Rep.?
Provide a short and direct response. 2.15. What is the ratio of the Production index(2004-2006) in 1962 in Vanuatu to that in Yemen, Rep.?
Make the answer very short. 2.12. What is the ratio of the Production index(2004-2006) of 1963 in Vanuatu to that in Yemen, Rep.?
Give a very brief answer. 2.28. What is the ratio of the Production index(2004-2006) of 1964 in Vanuatu to that in Yemen, Rep.?
Make the answer very short. 2.34. What is the ratio of the Production index(2004-2006) of 1961 in Venezuela to that in Vietnam?
Keep it short and to the point. 1.19. What is the ratio of the Production index(2004-2006) in 1962 in Venezuela to that in Vietnam?
Provide a short and direct response. 1.15. What is the ratio of the Production index(2004-2006) of 1963 in Venezuela to that in Vietnam?
Provide a short and direct response. 1.21. What is the ratio of the Production index(2004-2006) of 1964 in Venezuela to that in Vietnam?
Keep it short and to the point. 1.29. What is the ratio of the Production index(2004-2006) of 1961 in Venezuela to that in Virgin Islands?
Make the answer very short. 0.11. What is the ratio of the Production index(2004-2006) in 1962 in Venezuela to that in Virgin Islands?
Your response must be concise. 0.1. What is the ratio of the Production index(2004-2006) in 1963 in Venezuela to that in Virgin Islands?
Offer a very short reply. 0.11. What is the ratio of the Production index(2004-2006) in 1964 in Venezuela to that in Virgin Islands?
Make the answer very short. 0.08. What is the ratio of the Production index(2004-2006) in 1961 in Venezuela to that in Yemen, Rep.?
Provide a succinct answer. 0.88. What is the ratio of the Production index(2004-2006) in 1962 in Venezuela to that in Yemen, Rep.?
Your answer should be compact. 0.89. What is the ratio of the Production index(2004-2006) of 1963 in Venezuela to that in Yemen, Rep.?
Give a very brief answer. 0.91. What is the ratio of the Production index(2004-2006) in 1964 in Venezuela to that in Yemen, Rep.?
Make the answer very short. 0.97. What is the ratio of the Production index(2004-2006) in 1961 in Vietnam to that in Virgin Islands?
Your answer should be compact. 0.09. What is the ratio of the Production index(2004-2006) of 1962 in Vietnam to that in Virgin Islands?
Offer a very short reply. 0.09. What is the ratio of the Production index(2004-2006) in 1963 in Vietnam to that in Virgin Islands?
Ensure brevity in your answer.  0.09. What is the ratio of the Production index(2004-2006) of 1964 in Vietnam to that in Virgin Islands?
Ensure brevity in your answer.  0.06. What is the ratio of the Production index(2004-2006) of 1961 in Vietnam to that in Yemen, Rep.?
Ensure brevity in your answer.  0.74. What is the ratio of the Production index(2004-2006) in 1962 in Vietnam to that in Yemen, Rep.?
Offer a terse response. 0.77. What is the ratio of the Production index(2004-2006) of 1963 in Vietnam to that in Yemen, Rep.?
Make the answer very short. 0.75. What is the ratio of the Production index(2004-2006) of 1964 in Vietnam to that in Yemen, Rep.?
Keep it short and to the point. 0.75. What is the ratio of the Production index(2004-2006) of 1961 in Virgin Islands to that in Yemen, Rep.?
Your answer should be compact. 8.18. What is the ratio of the Production index(2004-2006) of 1962 in Virgin Islands to that in Yemen, Rep.?
Make the answer very short. 8.92. What is the ratio of the Production index(2004-2006) of 1963 in Virgin Islands to that in Yemen, Rep.?
Ensure brevity in your answer.  8.32. What is the ratio of the Production index(2004-2006) in 1964 in Virgin Islands to that in Yemen, Rep.?
Your answer should be very brief. 12.02. What is the difference between the highest and the second highest Production index(2004-2006) in 1961?
Your response must be concise. 170.31. What is the difference between the highest and the second highest Production index(2004-2006) of 1962?
Your response must be concise. 195.24. What is the difference between the highest and the second highest Production index(2004-2006) of 1963?
Provide a short and direct response. 178.72. What is the difference between the highest and the second highest Production index(2004-2006) in 1964?
Provide a succinct answer. 291.03. What is the difference between the highest and the lowest Production index(2004-2006) of 1961?
Provide a short and direct response. 210.29. What is the difference between the highest and the lowest Production index(2004-2006) in 1962?
Make the answer very short. 234.05. What is the difference between the highest and the lowest Production index(2004-2006) of 1963?
Give a very brief answer. 224.02. What is the difference between the highest and the lowest Production index(2004-2006) in 1964?
Provide a short and direct response. 338.76. 